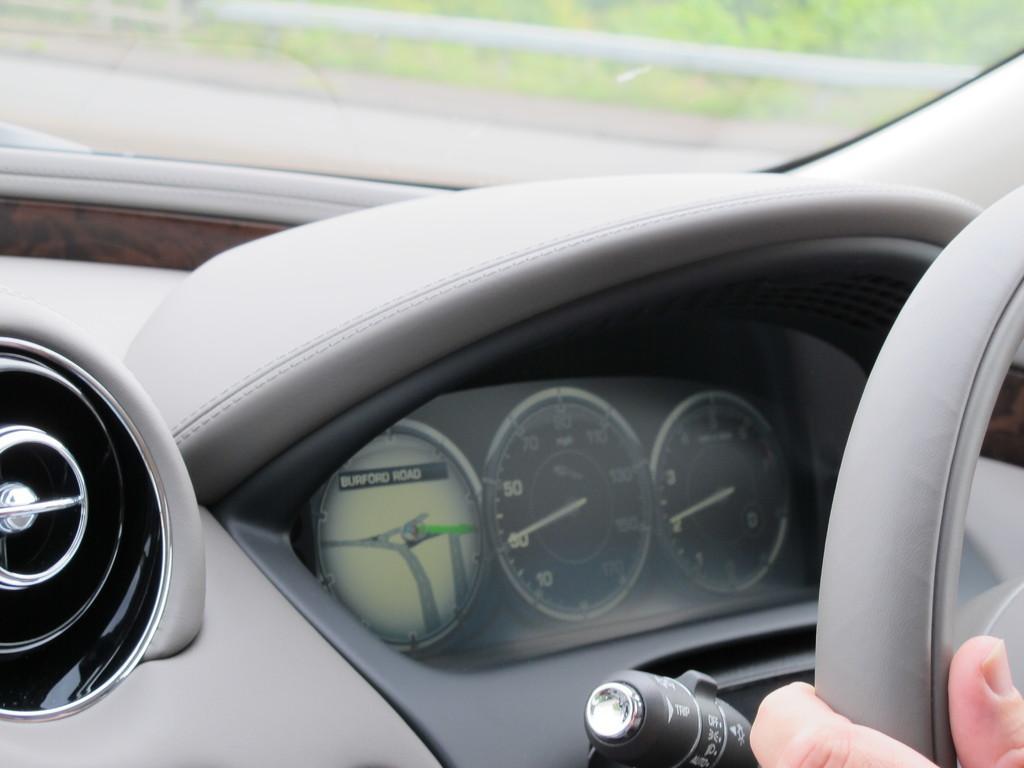How would you summarize this image in a sentence or two? In this picture we can see an inside view of a car, on the right side we can see steering, we can see fingers her, from the glass we can see plants. 